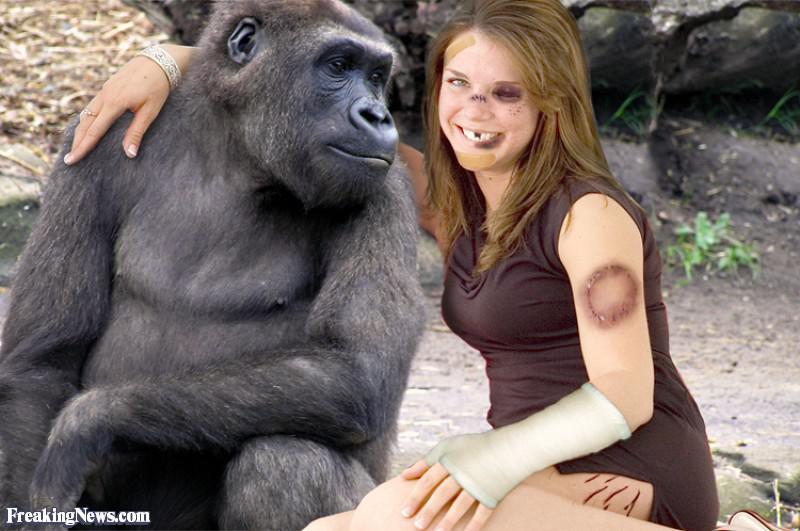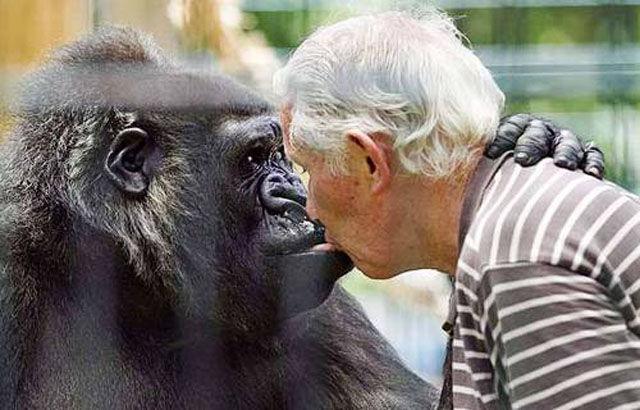The first image is the image on the left, the second image is the image on the right. Analyze the images presented: Is the assertion "Each image shows one person to the right of one gorilla, and the right image shows a gorilla face-to-face with and touching a person." valid? Answer yes or no. Yes. The first image is the image on the left, the second image is the image on the right. Analyze the images presented: Is the assertion "The left and right image contains the same number gorillas on the left and people on the right." valid? Answer yes or no. Yes. 